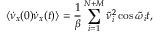<formula> <loc_0><loc_0><loc_500><loc_500>\left < \dot { \nu } _ { x } ( 0 ) \dot { \nu } _ { x } ( t ) \right > = { \frac { 1 } { \beta } } \sum _ { i = 1 } ^ { N + M } \tilde { \nu } _ { i } ^ { 2 } \cos \tilde { \omega } _ { i } t ,</formula> 